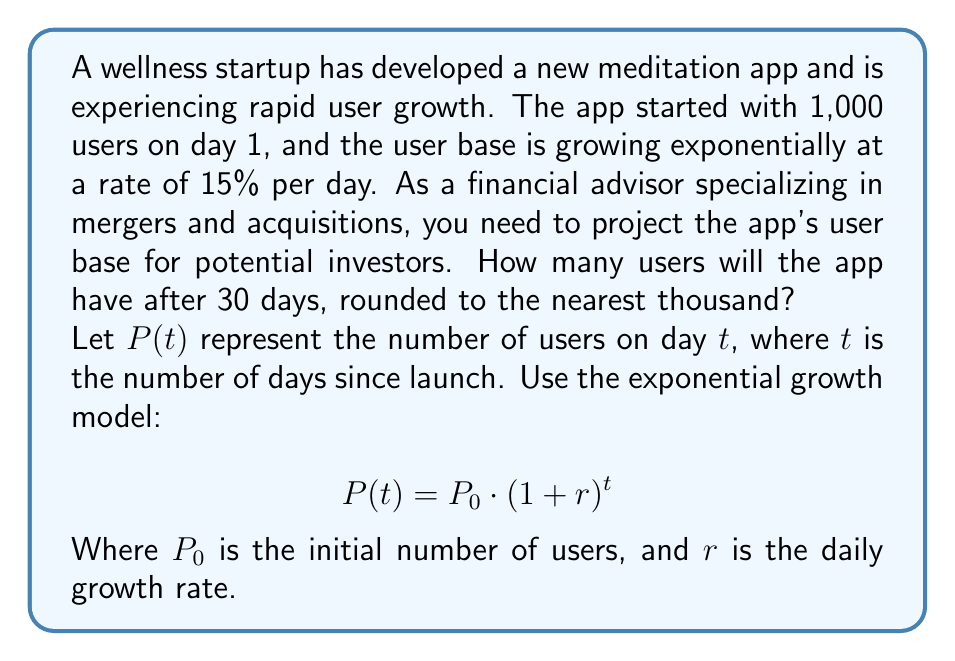Solve this math problem. To solve this problem, we'll use the exponential growth model and plug in the given values:

1. Initial number of users, $P_0 = 1,000$
2. Daily growth rate, $r = 15\% = 0.15$
3. Number of days, $t = 30$

Let's substitute these values into the exponential growth formula:

$$P(30) = 1,000 \cdot (1 + 0.15)^{30}$$

Now, let's calculate step by step:

1. First, calculate $(1 + 0.15)^{30}$:
   $$(1.15)^{30} \approx 66.2117$$

2. Multiply this result by the initial number of users:
   $$1,000 \cdot 66.2117 = 66,211.7$$

3. Round the result to the nearest thousand:
   $$66,211.7 \approx 66,000$$

Therefore, after 30 days, the app will have approximately 66,000 users.
Answer: 66,000 users 